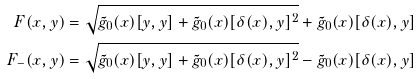<formula> <loc_0><loc_0><loc_500><loc_500>F ( x , y ) & = \sqrt { \tilde { g } _ { 0 } ( x ) [ y , y ] + \tilde { g } _ { 0 } ( x ) [ \delta ( x ) , y ] ^ { 2 } } + \tilde { g } _ { 0 } ( x ) [ \delta ( x ) , y ] \\ F _ { - } ( x , y ) & = \sqrt { \tilde { g } _ { 0 } ( x ) [ y , y ] + \tilde { g } _ { 0 } ( x ) [ \delta ( x ) , y ] ^ { 2 } } - \tilde { g } _ { 0 } ( x ) [ \delta ( x ) , y ]</formula> 